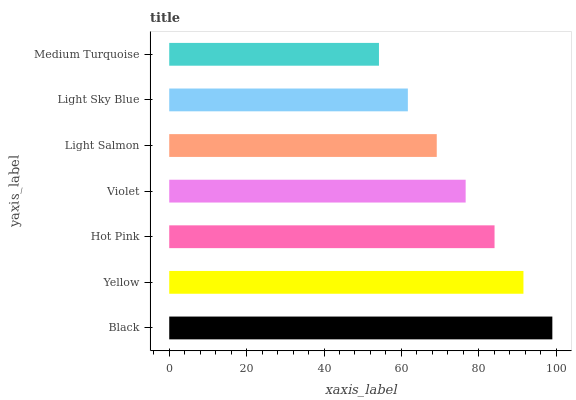Is Medium Turquoise the minimum?
Answer yes or no. Yes. Is Black the maximum?
Answer yes or no. Yes. Is Yellow the minimum?
Answer yes or no. No. Is Yellow the maximum?
Answer yes or no. No. Is Black greater than Yellow?
Answer yes or no. Yes. Is Yellow less than Black?
Answer yes or no. Yes. Is Yellow greater than Black?
Answer yes or no. No. Is Black less than Yellow?
Answer yes or no. No. Is Violet the high median?
Answer yes or no. Yes. Is Violet the low median?
Answer yes or no. Yes. Is Medium Turquoise the high median?
Answer yes or no. No. Is Light Salmon the low median?
Answer yes or no. No. 